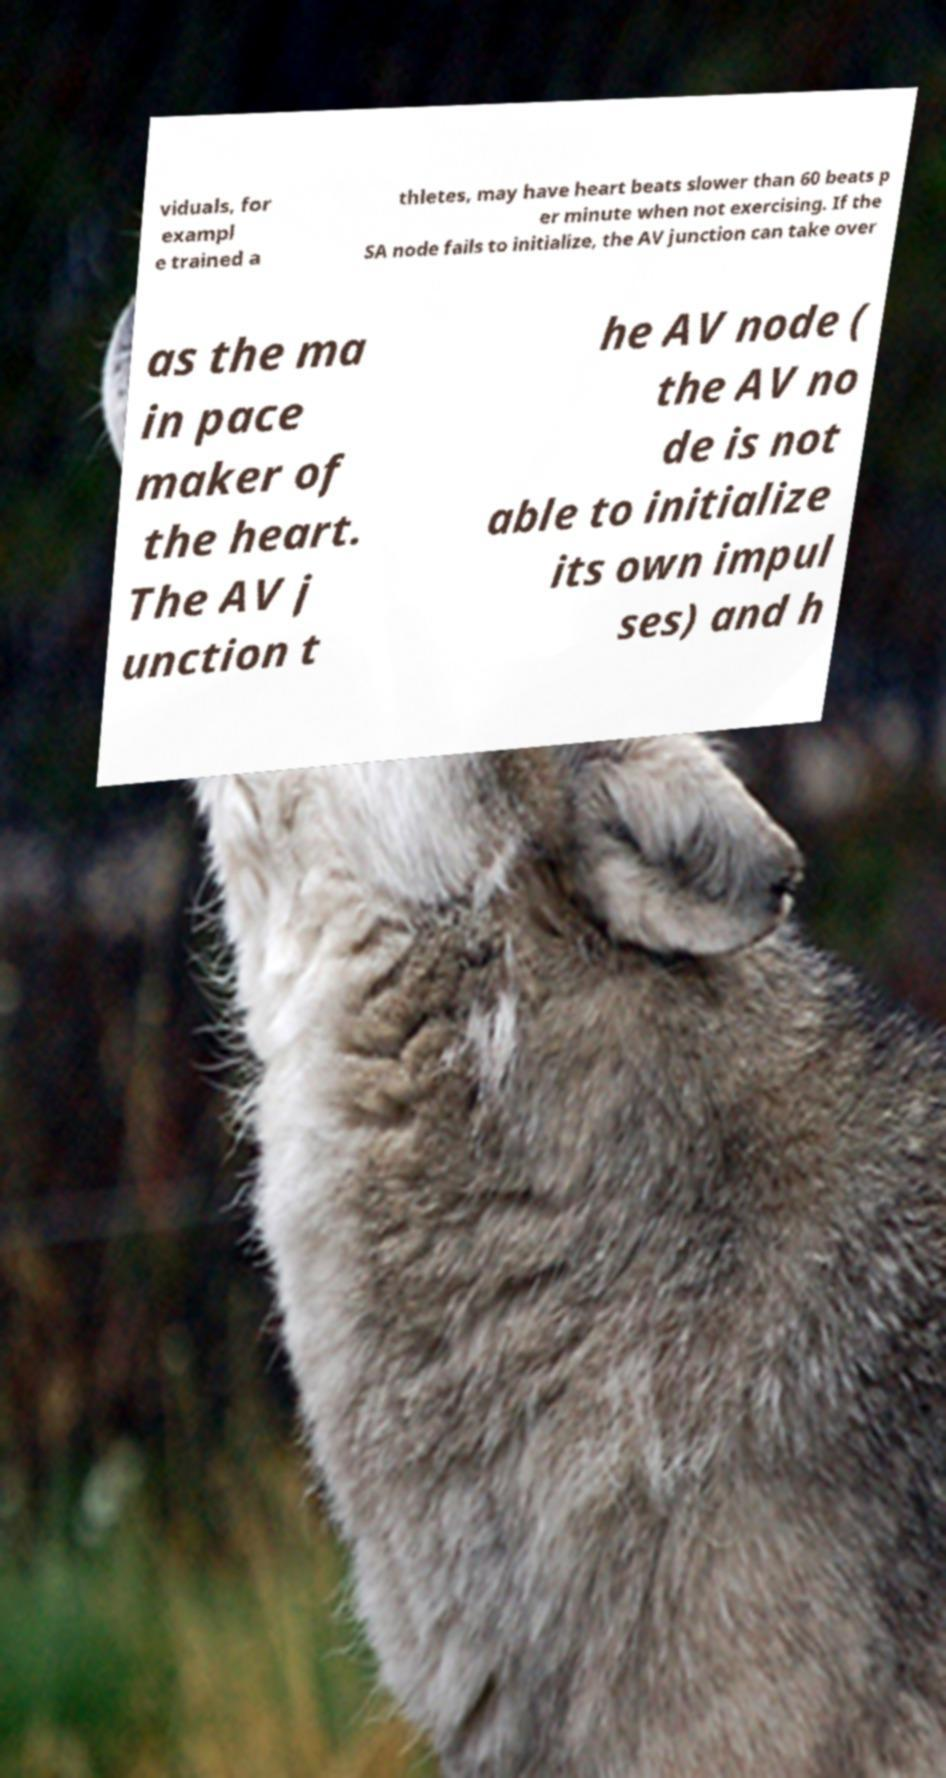What messages or text are displayed in this image? I need them in a readable, typed format. viduals, for exampl e trained a thletes, may have heart beats slower than 60 beats p er minute when not exercising. If the SA node fails to initialize, the AV junction can take over as the ma in pace maker of the heart. The AV j unction t he AV node ( the AV no de is not able to initialize its own impul ses) and h 